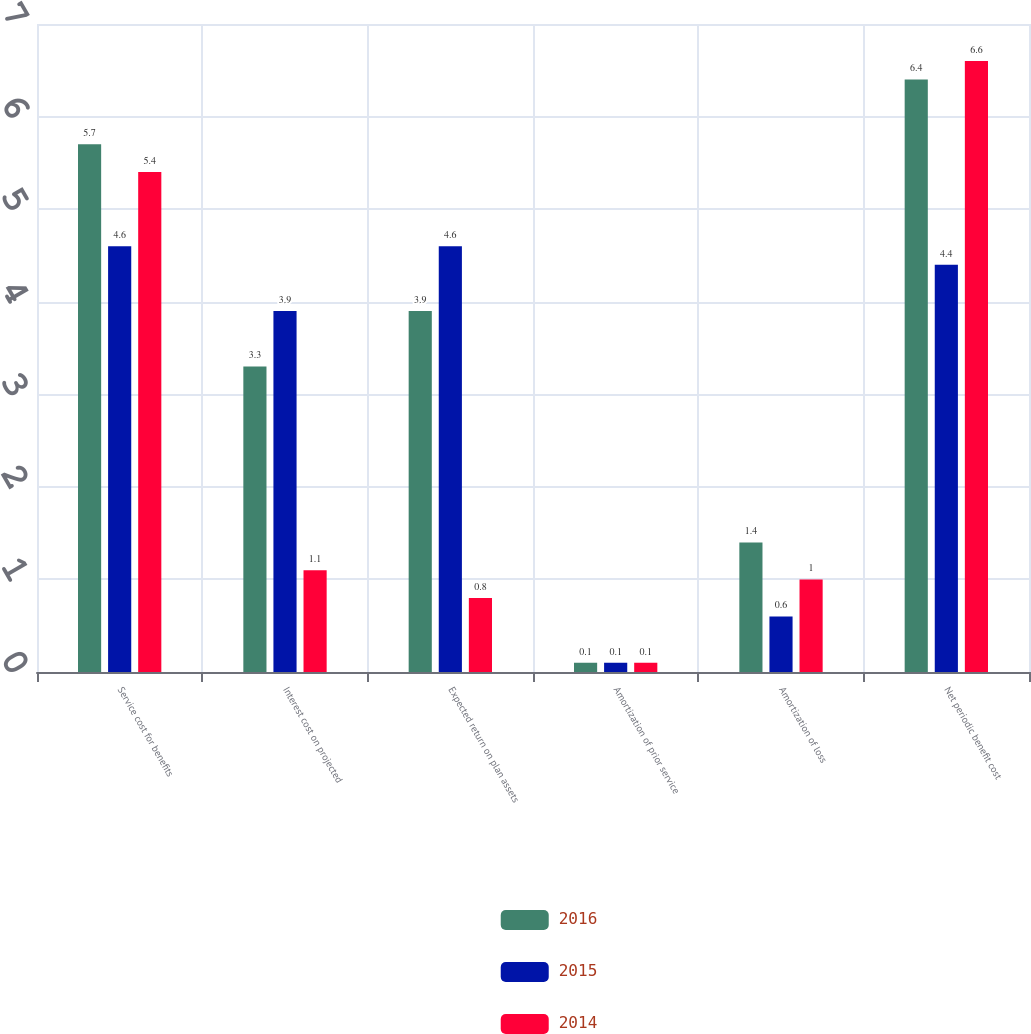Convert chart to OTSL. <chart><loc_0><loc_0><loc_500><loc_500><stacked_bar_chart><ecel><fcel>Service cost for benefits<fcel>Interest cost on projected<fcel>Expected return on plan assets<fcel>Amortization of prior service<fcel>Amortization of loss<fcel>Net periodic benefit cost<nl><fcel>2016<fcel>5.7<fcel>3.3<fcel>3.9<fcel>0.1<fcel>1.4<fcel>6.4<nl><fcel>2015<fcel>4.6<fcel>3.9<fcel>4.6<fcel>0.1<fcel>0.6<fcel>4.4<nl><fcel>2014<fcel>5.4<fcel>1.1<fcel>0.8<fcel>0.1<fcel>1<fcel>6.6<nl></chart> 